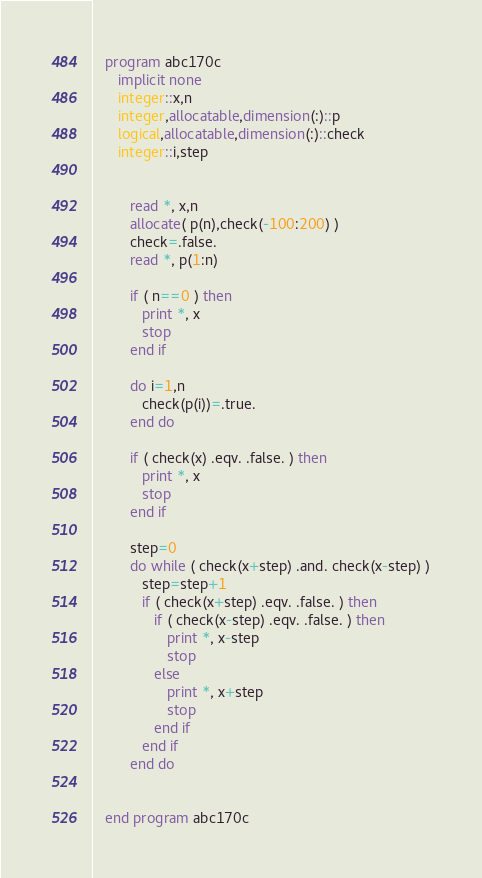Convert code to text. <code><loc_0><loc_0><loc_500><loc_500><_FORTRAN_>   program abc170c
      implicit none
      integer::x,n
      integer,allocatable,dimension(:)::p
      logical,allocatable,dimension(:)::check
      integer::i,step


         read *, x,n
         allocate( p(n),check(-100:200) )
         check=.false.
         read *, p(1:n)

         if ( n==0 ) then
            print *, x
            stop
         end if

         do i=1,n
            check(p(i))=.true.
         end do

         if ( check(x) .eqv. .false. ) then
            print *, x
            stop
         end if

         step=0
         do while ( check(x+step) .and. check(x-step) )
            step=step+1
            if ( check(x+step) .eqv. .false. ) then
               if ( check(x-step) .eqv. .false. ) then
                  print *, x-step
                  stop
               else
                  print *, x+step
                  stop
               end if
            end if
         end do


   end program abc170c</code> 